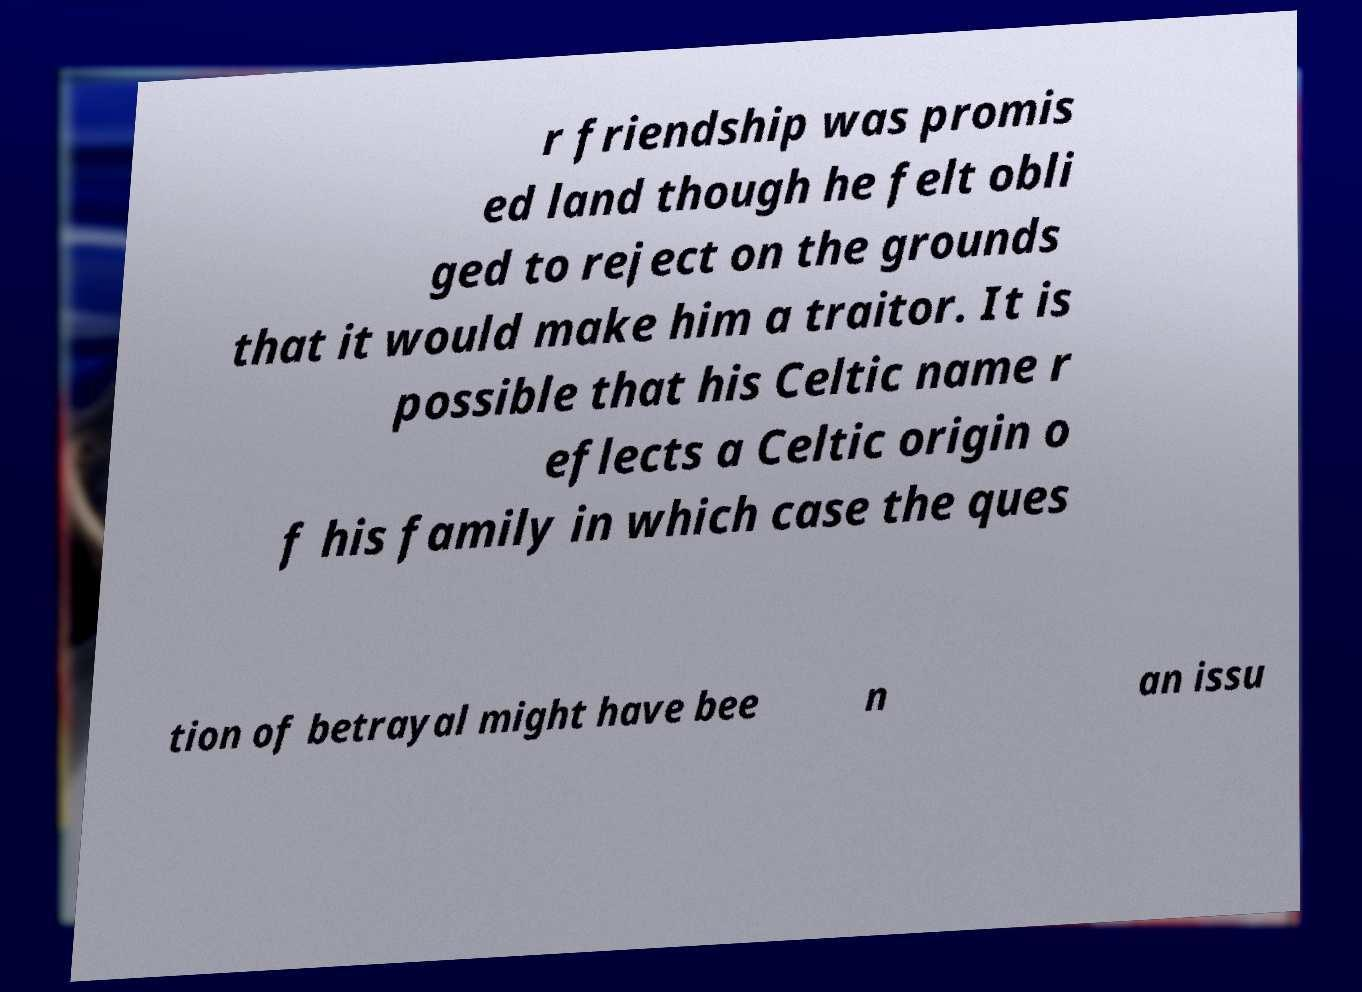What messages or text are displayed in this image? I need them in a readable, typed format. r friendship was promis ed land though he felt obli ged to reject on the grounds that it would make him a traitor. It is possible that his Celtic name r eflects a Celtic origin o f his family in which case the ques tion of betrayal might have bee n an issu 